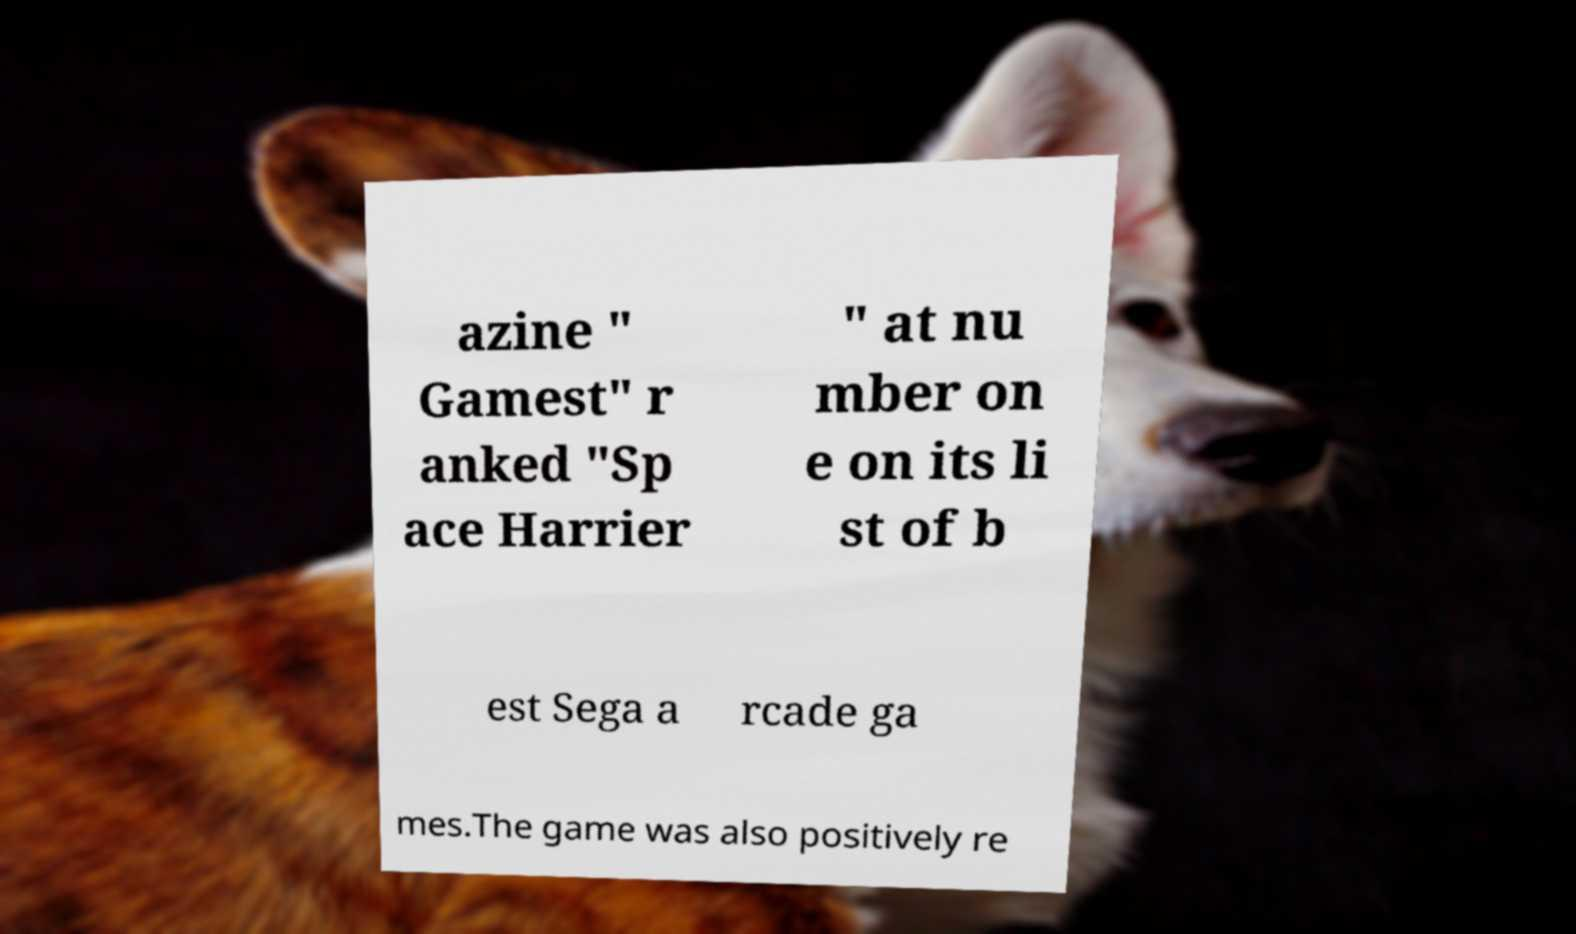Can you accurately transcribe the text from the provided image for me? azine " Gamest" r anked "Sp ace Harrier " at nu mber on e on its li st of b est Sega a rcade ga mes.The game was also positively re 